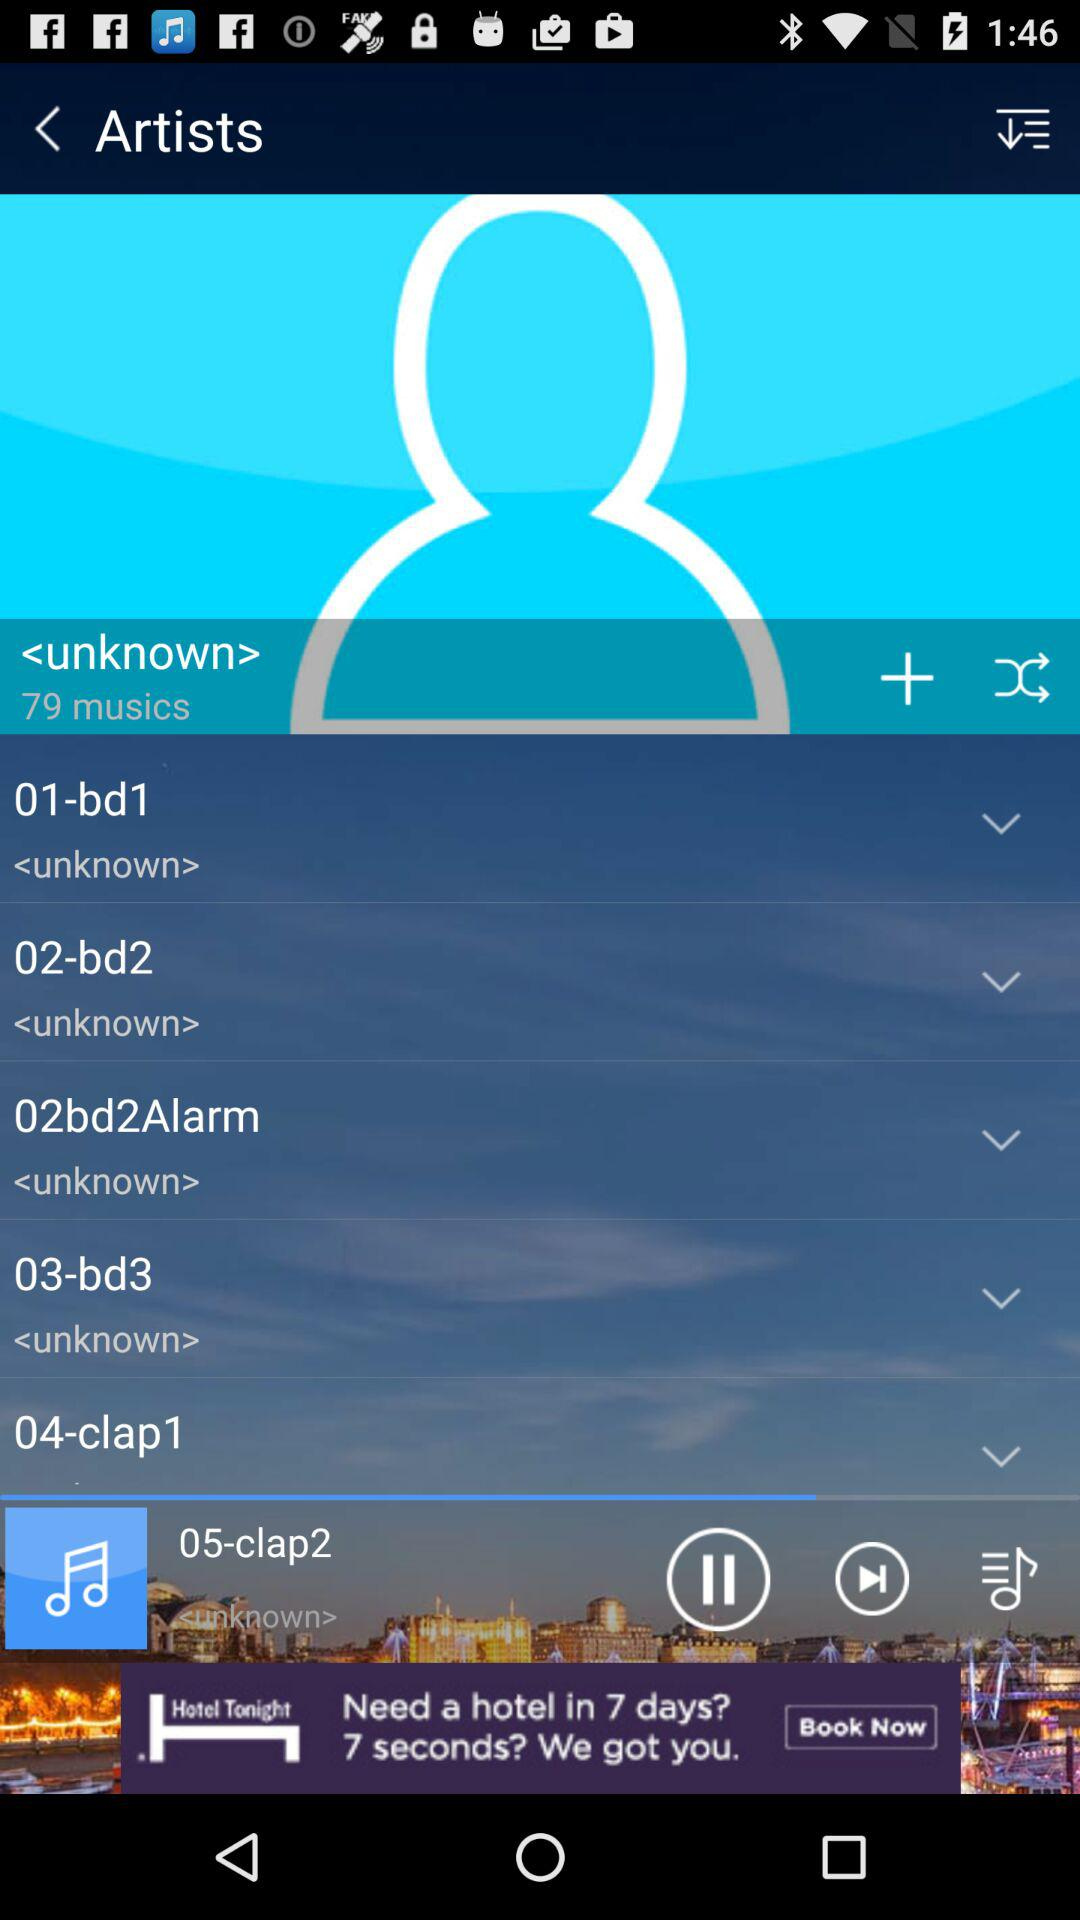How many musics have a downward arrow?
Answer the question using a single word or phrase. 5 